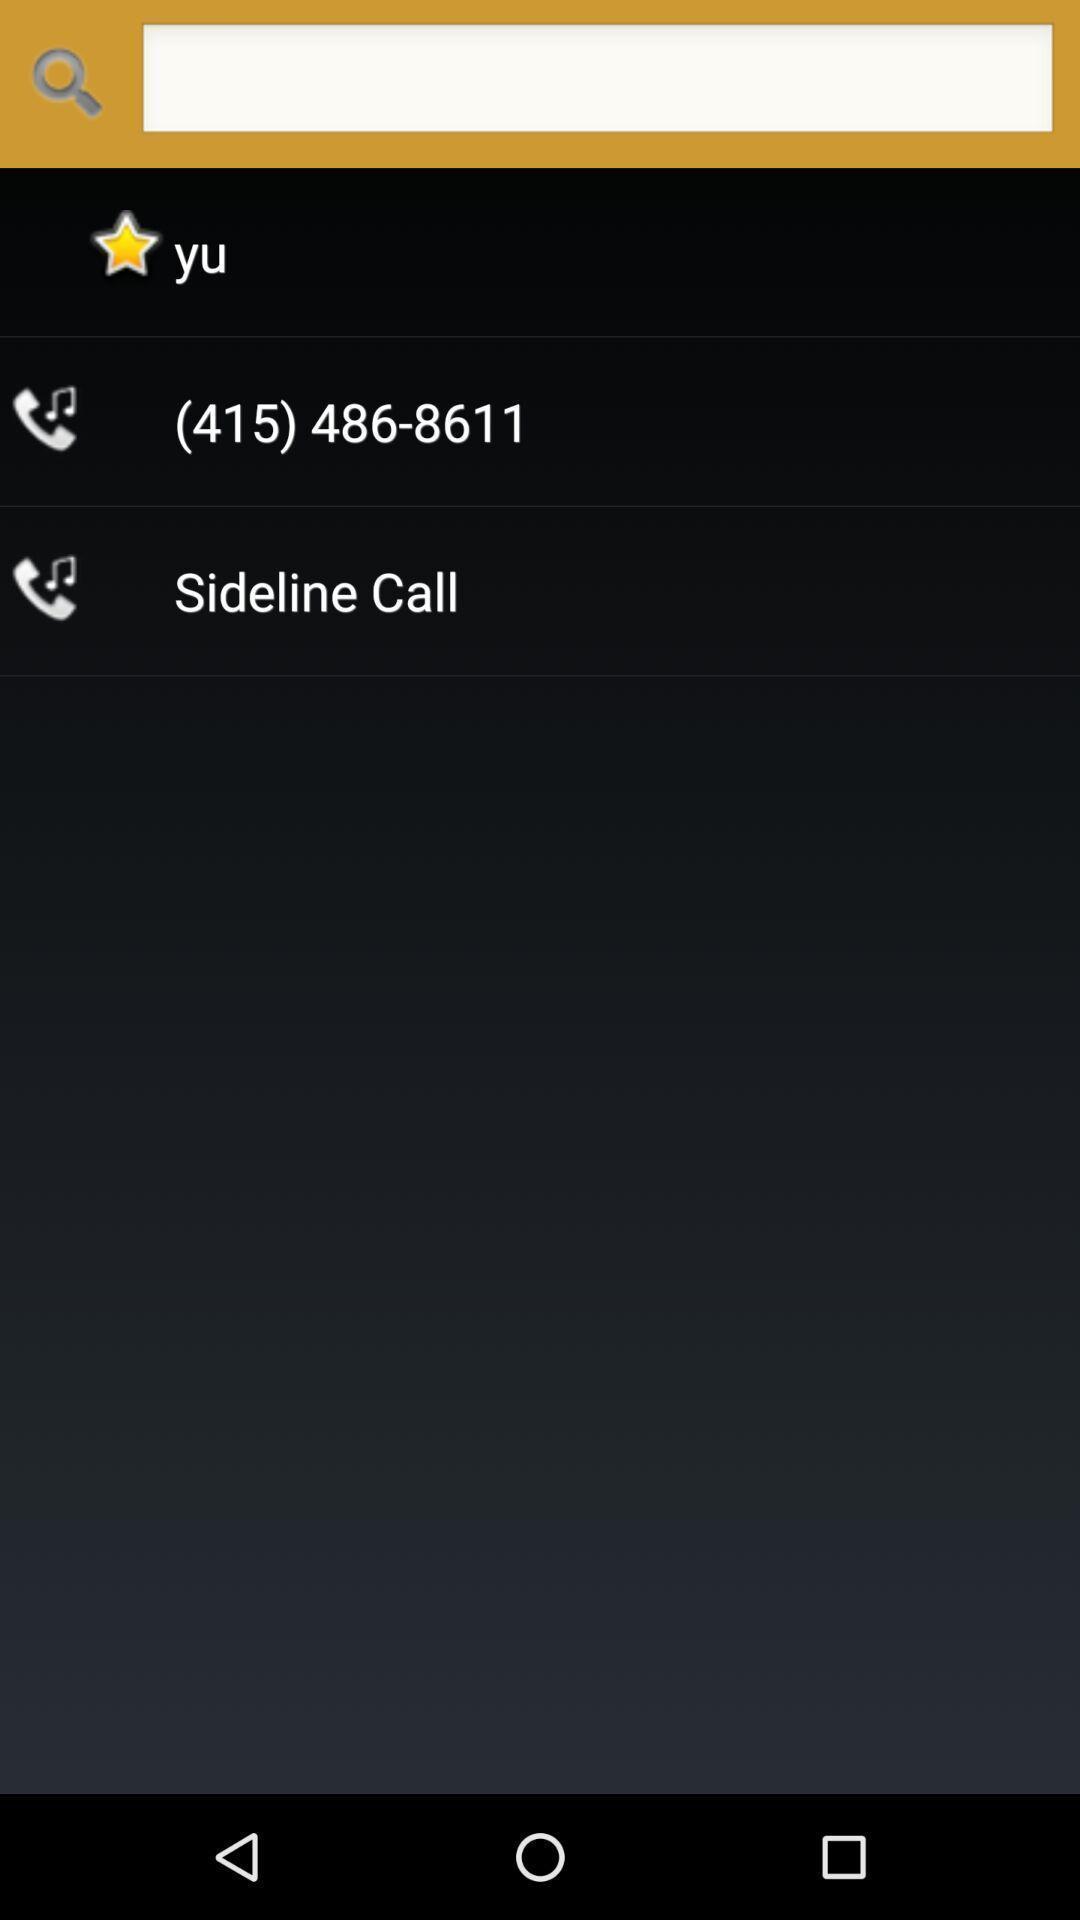Provide a textual representation of this image. Screen displaying a search bar with contact details. 